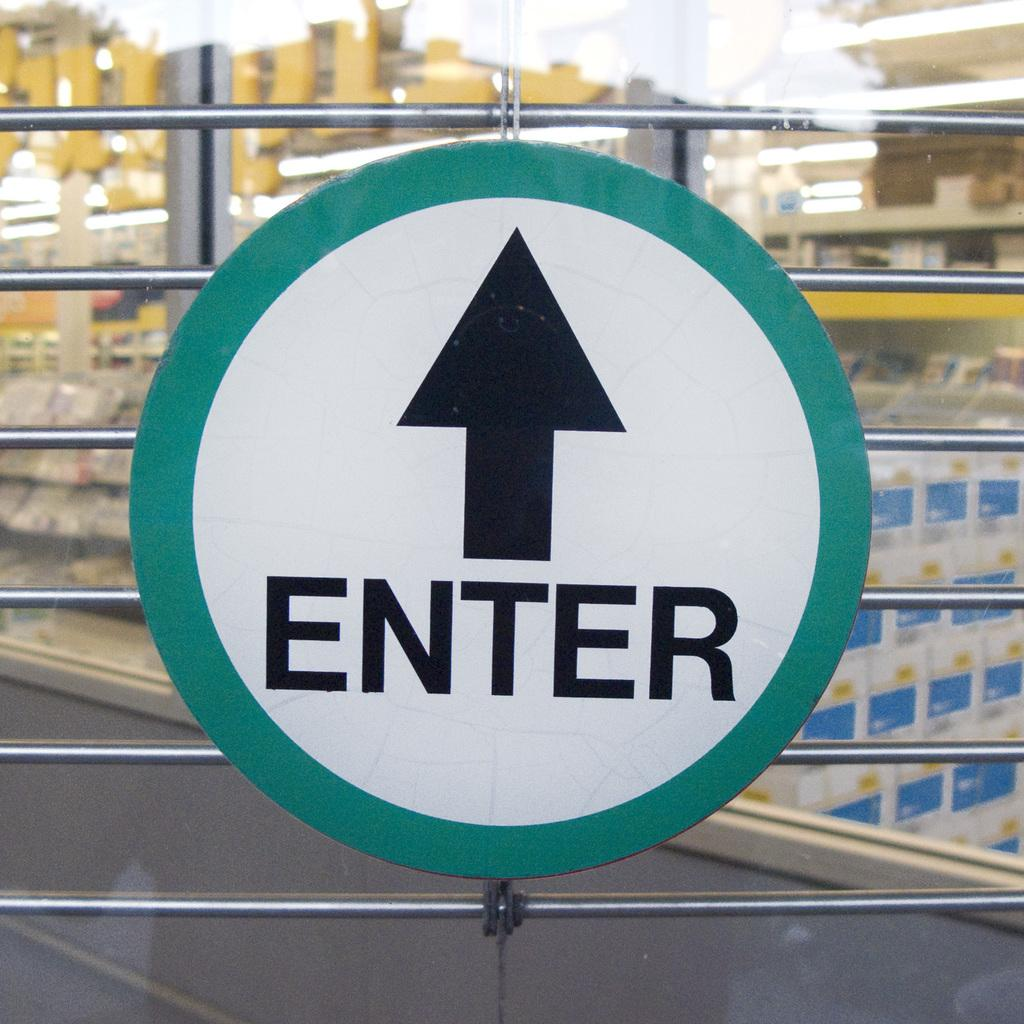<image>
Render a clear and concise summary of the photo. The sign shown tells people where to enter. 